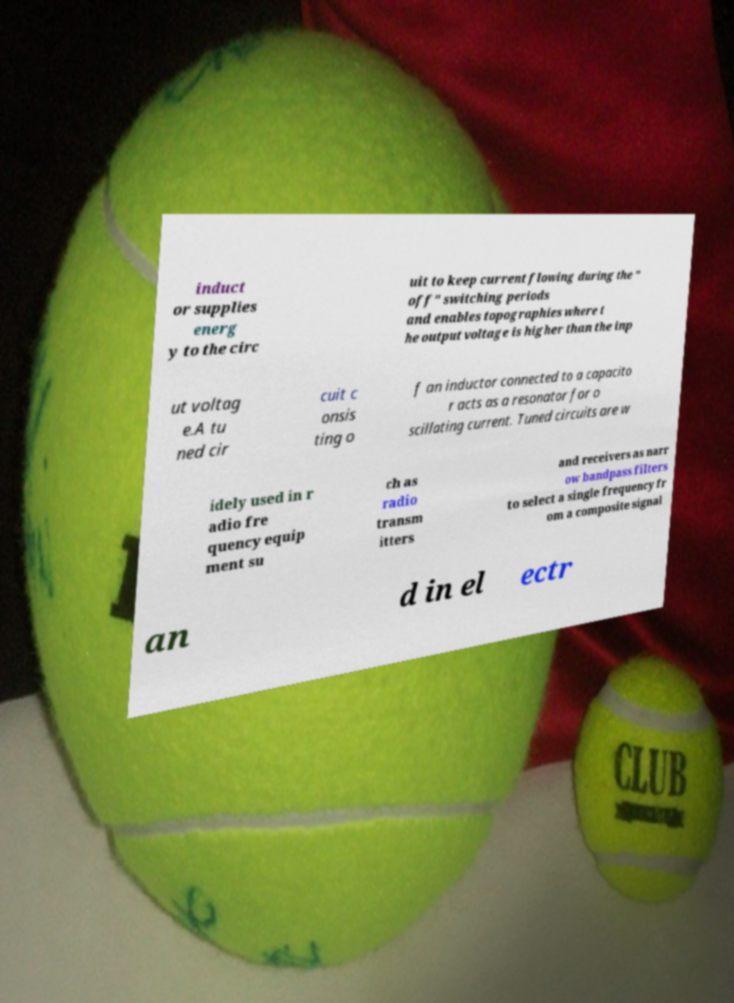I need the written content from this picture converted into text. Can you do that? induct or supplies energ y to the circ uit to keep current flowing during the " off" switching periods and enables topographies where t he output voltage is higher than the inp ut voltag e.A tu ned cir cuit c onsis ting o f an inductor connected to a capacito r acts as a resonator for o scillating current. Tuned circuits are w idely used in r adio fre quency equip ment su ch as radio transm itters and receivers as narr ow bandpass filters to select a single frequency fr om a composite signal an d in el ectr 